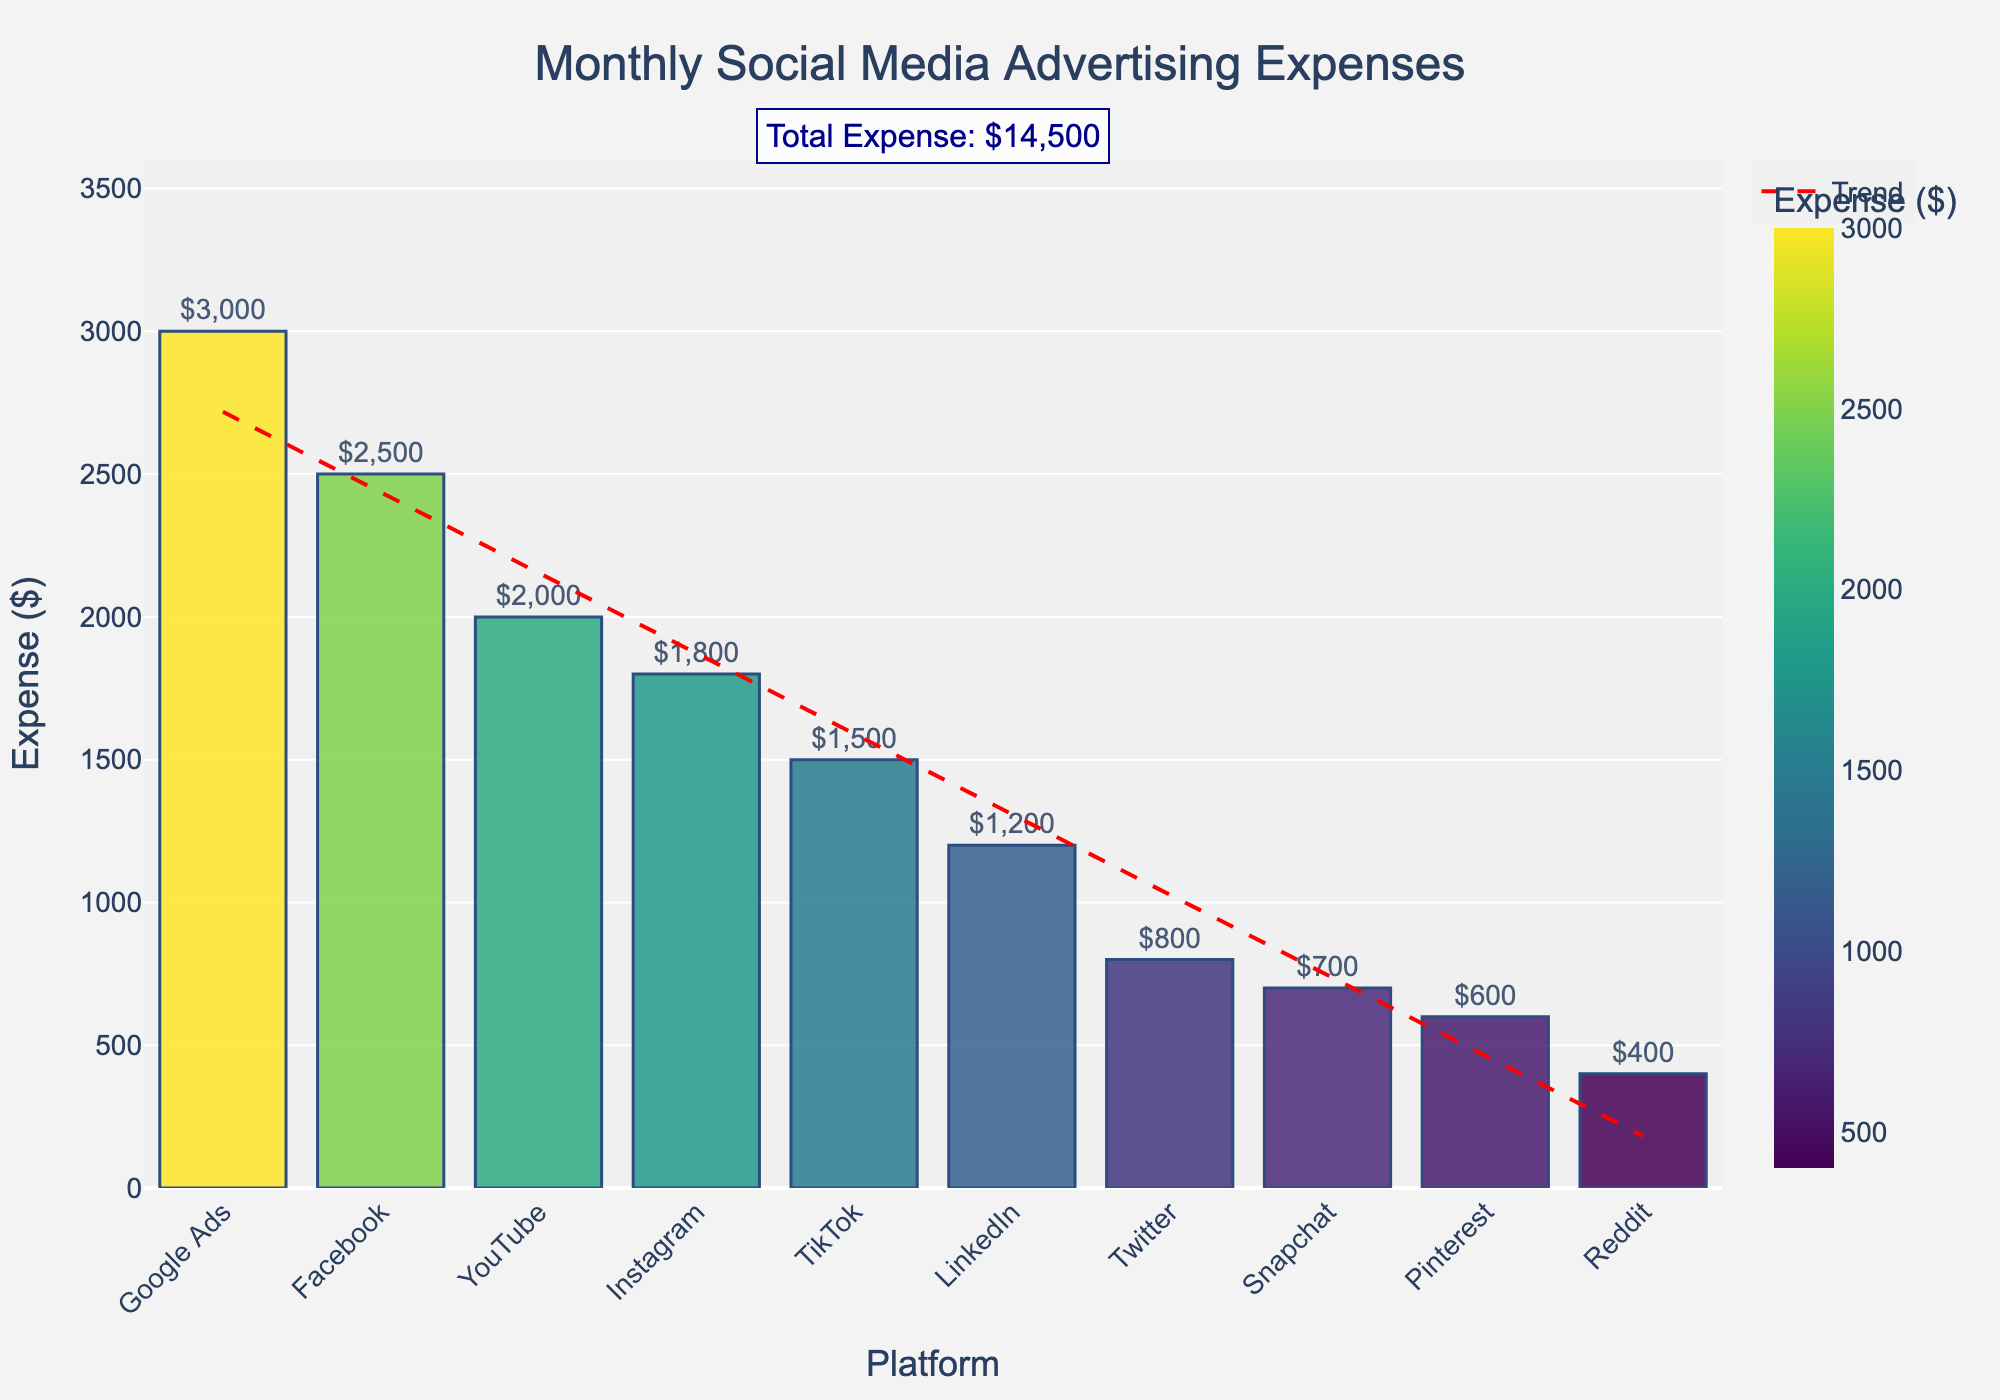Which platform has the highest advertising expense? The platform with the highest bar represents the highest advertising expense. The bar for Google Ads is the tallest.
Answer: Google Ads What is the total monthly expense for Twitter and LinkedIn combined? The heights of the bars for Twitter and LinkedIn indicate their expenses are $800 and $1200 respectively. Adding these together gives $800 + $1200 = $2000.
Answer: $2000 How much more does Facebook spend on advertising compared to Pinterest? The height of the bar for Facebook is $2500 and for Pinterest is $600. Subtracting these values gives $2500 - $600 = $1900.
Answer: $1900 Which platform has the smallest advertising expense? The platform with the shortest bar represents the smallest advertising expense. The bar for Reddit is the shortest.
Answer: Reddit What is the average advertising expense across all platforms? First, sum all the expenses ($2500 + $1800 + $800 + $1200 + $1500 + $600 + $2000 + $700 + $400 + $3000 = $15500). Then, divide by the number of platforms (10). The average expense is $15500 / 10 = $1550.
Answer: $1550 How do Instagram's expenses compare to those of TikTok? The height of the bar for Instagram is $1800 and for TikTok is $1500. Instagram's expenses are greater than TikTok's.
Answer: Instagram > TikTok What is the difference in expense between the highest and lowest spending platforms? The highest expense is Google Ads at $3000 and the lowest is Reddit at $400. Subtracting these values gives $3000 - $400 = $2600.
Answer: $2600 Which platforms have an expense greater than $1000? Platforms where the bar extends above the $1000 mark are Facebook, Instagram, LinkedIn, TikTok, YouTube, and Google Ads.
Answer: Facebook, Instagram, LinkedIn, TikTok, YouTube, Google Ads What portion of the total expense does YouTube's platform represent? YouTube's expense is $2000. The total expense is $15500. The portion is calculated as ($2000 / $15500) * 100% ≈ 12.9%.
Answer: 12.9% What is the trend in expenses shown by the red dashed line? The red dashed line in the graph indicates a downward trend in expenses from the highest to the lowest.
Answer: Downward trend 